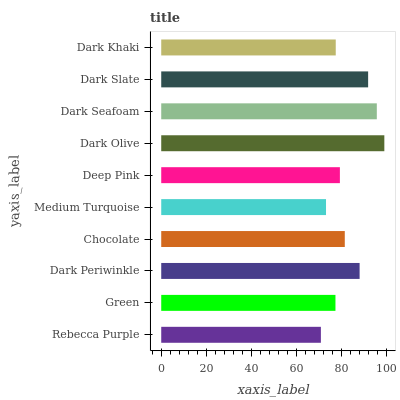Is Rebecca Purple the minimum?
Answer yes or no. Yes. Is Dark Olive the maximum?
Answer yes or no. Yes. Is Green the minimum?
Answer yes or no. No. Is Green the maximum?
Answer yes or no. No. Is Green greater than Rebecca Purple?
Answer yes or no. Yes. Is Rebecca Purple less than Green?
Answer yes or no. Yes. Is Rebecca Purple greater than Green?
Answer yes or no. No. Is Green less than Rebecca Purple?
Answer yes or no. No. Is Chocolate the high median?
Answer yes or no. Yes. Is Deep Pink the low median?
Answer yes or no. Yes. Is Medium Turquoise the high median?
Answer yes or no. No. Is Dark Olive the low median?
Answer yes or no. No. 